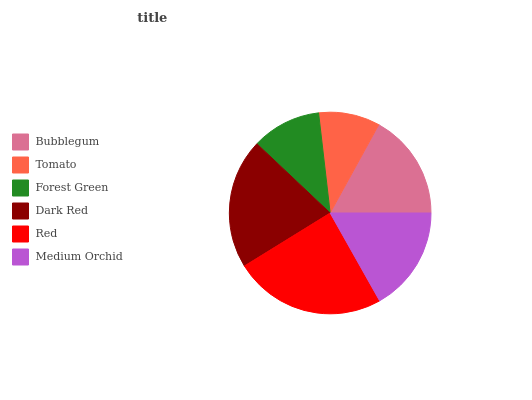Is Tomato the minimum?
Answer yes or no. Yes. Is Red the maximum?
Answer yes or no. Yes. Is Forest Green the minimum?
Answer yes or no. No. Is Forest Green the maximum?
Answer yes or no. No. Is Forest Green greater than Tomato?
Answer yes or no. Yes. Is Tomato less than Forest Green?
Answer yes or no. Yes. Is Tomato greater than Forest Green?
Answer yes or no. No. Is Forest Green less than Tomato?
Answer yes or no. No. Is Bubblegum the high median?
Answer yes or no. Yes. Is Medium Orchid the low median?
Answer yes or no. Yes. Is Tomato the high median?
Answer yes or no. No. Is Dark Red the low median?
Answer yes or no. No. 